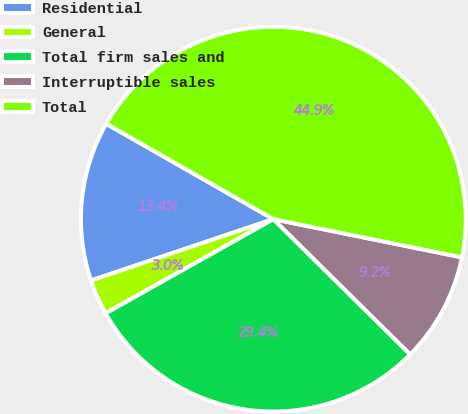Convert chart to OTSL. <chart><loc_0><loc_0><loc_500><loc_500><pie_chart><fcel>Residential<fcel>General<fcel>Total firm sales and<fcel>Interruptible sales<fcel>Total<nl><fcel>13.42%<fcel>2.98%<fcel>29.45%<fcel>9.22%<fcel>44.93%<nl></chart> 